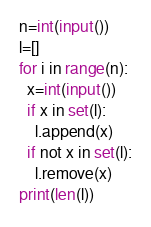<code> <loc_0><loc_0><loc_500><loc_500><_Python_>n=int(input())
l=[]
for i in range(n):
  x=int(input())
  if x in set(l):
    l.append(x)
  if not x in set(l):
    l.remove(x)
print(len(l))</code> 